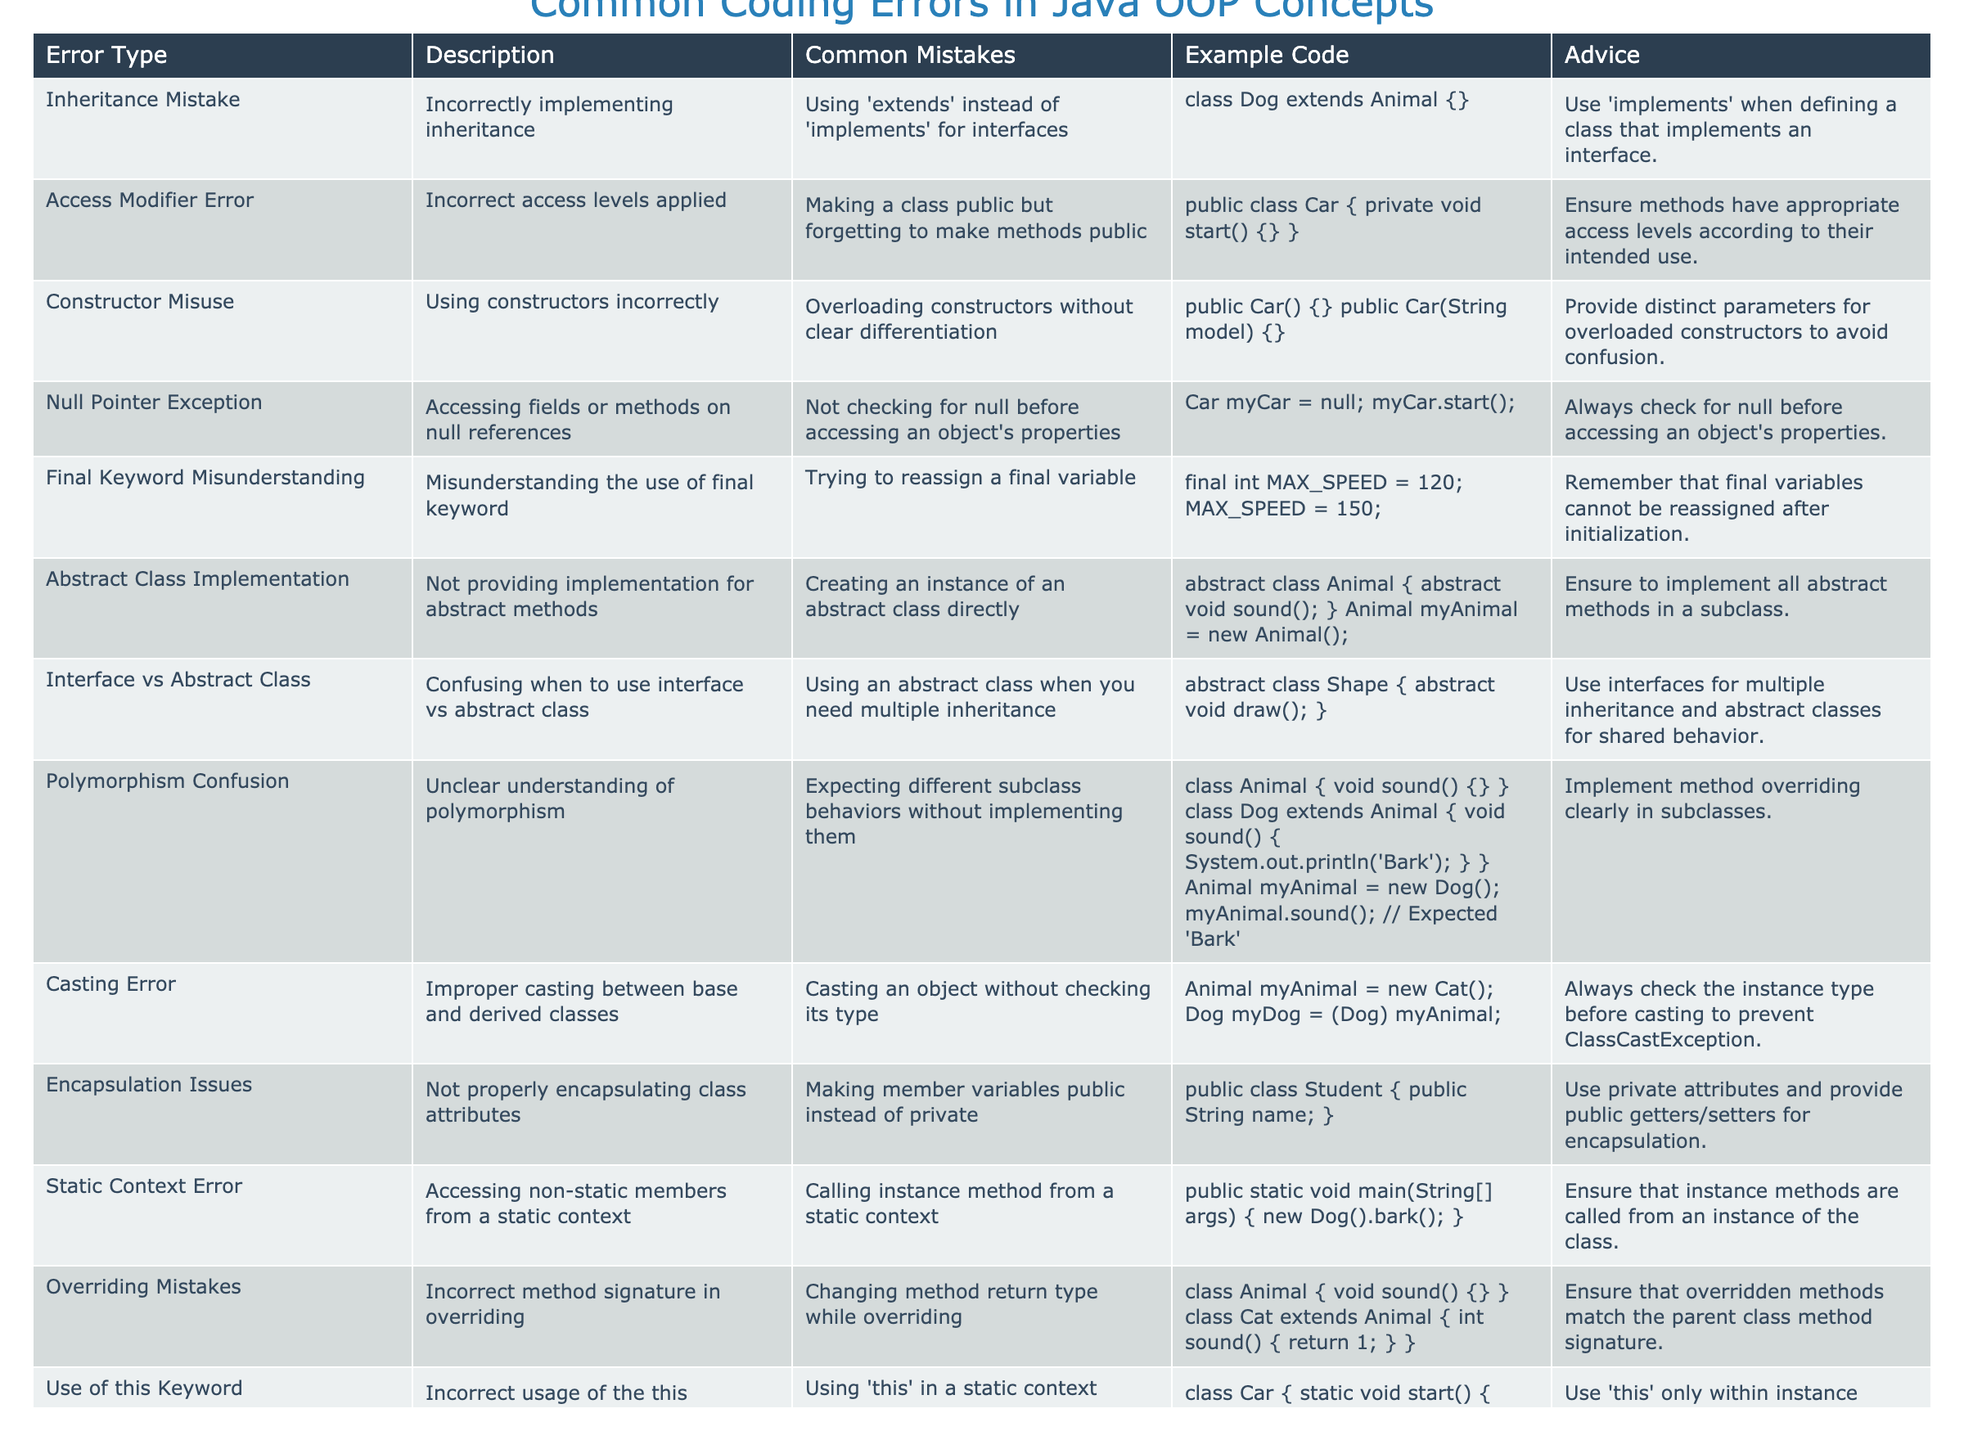What are the most common mistakes associated with inheritance? The table shows "Using 'extends' instead of 'implements' for interfaces" as a common mistake related to inheritance.
Answer: Using 'extends' instead of 'implements' for interfaces What should be used to implement an interface? According to the advice given for inheritance mistakes, 'implements' should be used when defining a class that implements an interface.
Answer: 'implements' Is it correct to access non-static members from a static context? The advice states that instance methods should not be called from a static context, hence it is not correct.
Answer: No How many errors are related to access modifiers? There is one error associated with access modifiers mentioned in the table.
Answer: 1 What is the general advice given for avoiding Null Pointer Exceptions? The advice emphasizes always checking for null before accessing an object's properties.
Answer: Always check for null Which error involves improper casting between classes? The table lists "Casting Error" as the error type related to improper casting between base and derived classes.
Answer: Casting Error What is the relationship between abstract classes and subclasses? The table advises ensuring to implement all abstract methods in a subclass, indicating a direct relationship between abstract classes and their subclasses.
Answer: Abstract classes need subclasses for implementation Are final variables allowed to be reassigned after initialization? The table states that final variables cannot be reassigned, so the answer is no.
Answer: No How can one avoid confusion with overloaded constructors? The advice highlights providing distinct parameters for overloaded constructors to avoid confusion.
Answer: Provide distinct parameters What is the recommended access level for member variables? The advice suggests using private attributes and providing public getters/setters for encapsulation to maintain access levels.
Answer: Private attributes with public getters/setters Which error is associated with incorrect usage of the 'this' keyword? The error type mentioned is "Use of this Keyword" indicating the improper usage of 'this' in a static context.
Answer: Use of this Keyword 